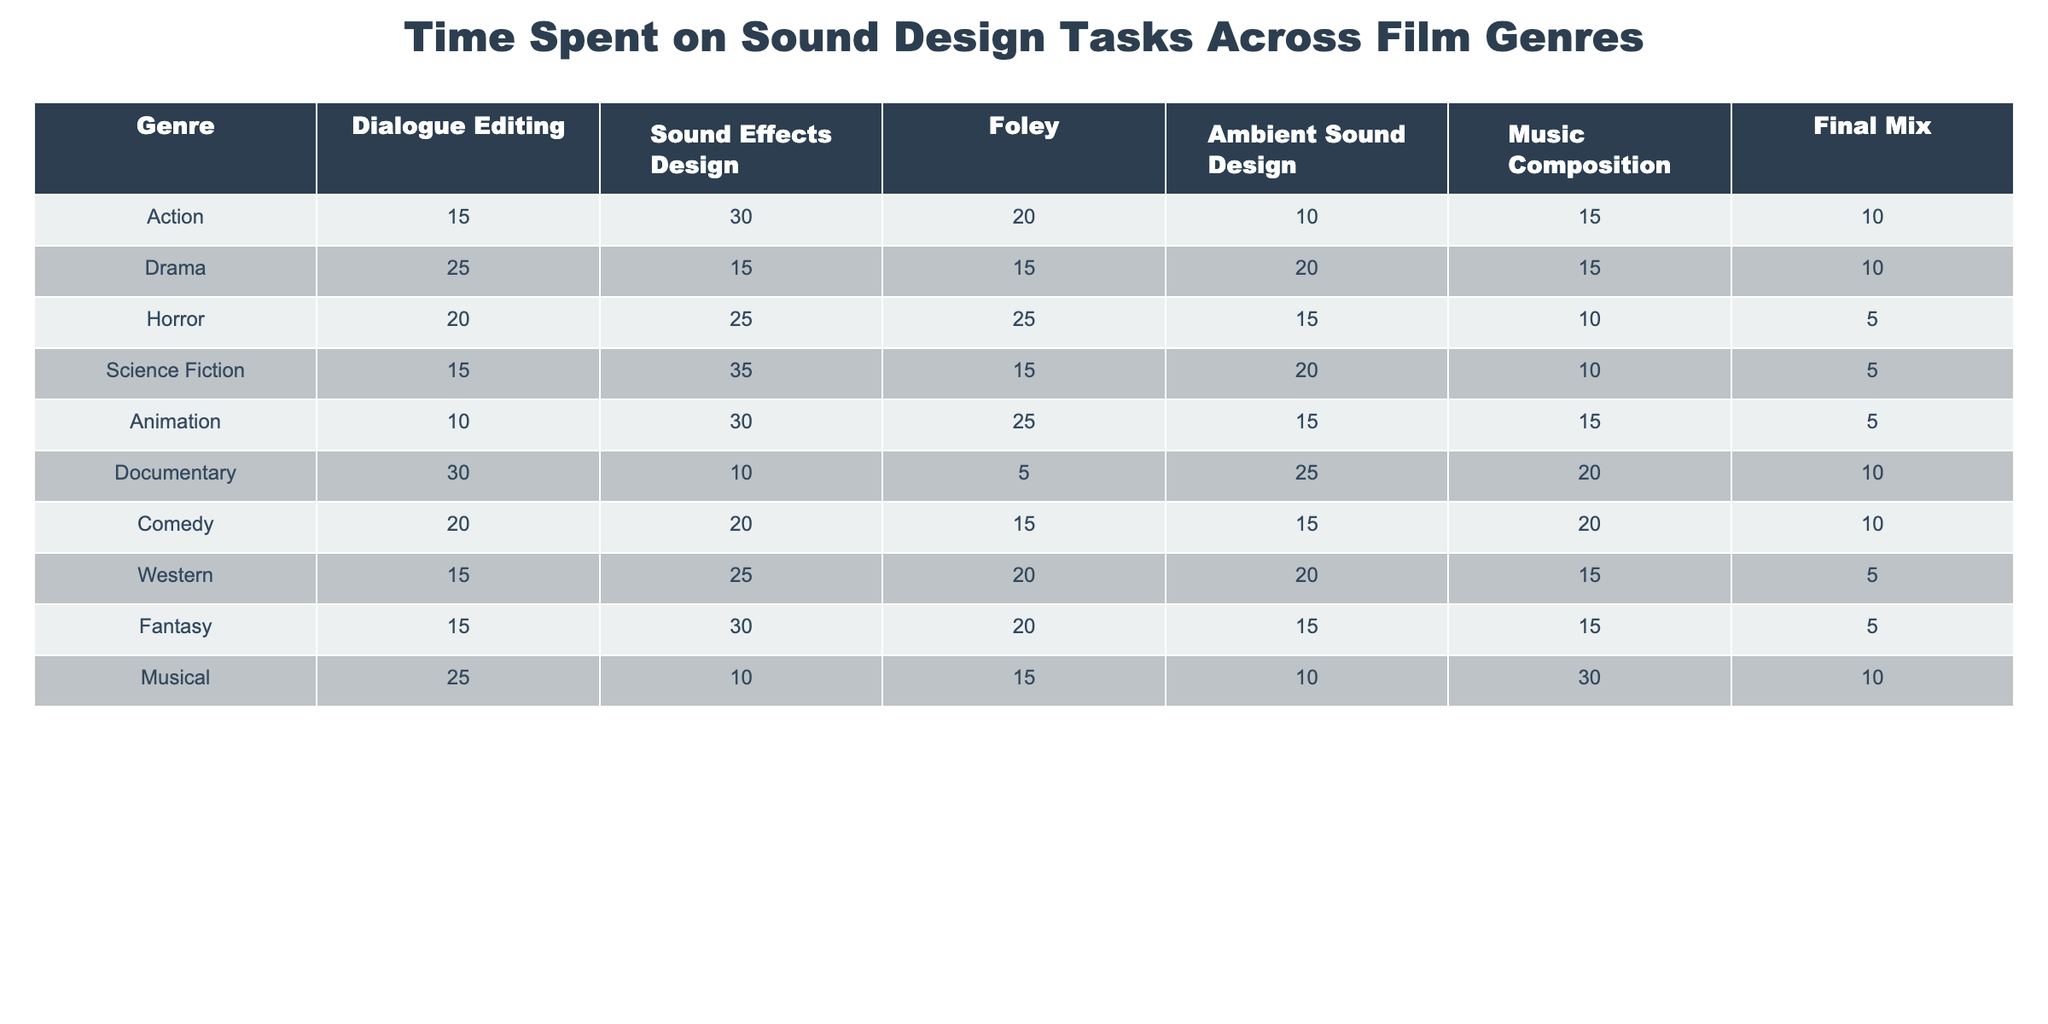What is the highest time spent on Dialogue Editing across all genres? The table shows that Documentary has the highest time spent on Dialogue Editing at 30 minutes.
Answer: 30 Which genre spends the most time on Ambient Sound Design? According to the table, Documentary spends the most time on Ambient Sound Design with a total of 25 minutes.
Answer: 25 What is the total time spent on Sound Effects Design in the Action genre? The Action genre has 30 minutes spent on Sound Effects Design, which is directly stated in the table.
Answer: 30 Does the genre Animation spend more time on Foley or Music Composition? Animation spends 25 minutes on Foley and 15 minutes on Music Composition; therefore, it spends more time on Foley.
Answer: Yes What genre has the lowest total time spent on all tasks? To find the genre with the lowest total time, we add the time for each task in every genre. The genre with the lowest total is Musical with 90 minutes.
Answer: Musical Which genre has the largest difference in time between Sound Effects Design and Foley? For Action, the time spent on Sound Effects Design is 30 minutes and on Foley is 20 minutes, resulting in a difference of 10 minutes. The largest difference is in Horror, with 25 minutes for Sound Effects and 25 for Foley, yielding a difference of 0. The genre with the largest difference is Action.
Answer: Action What is the average time spent on Music Composition across all genres? The Music Composition times are 15, 15, 10, 10, 15, 20, 20, 15, 30, and 30. Summing these values provides 175 minutes, and dividing by 10 (the number of genres) results in an average of 17.5 minutes.
Answer: 17.5 In which genre is the time spent on Dialogue Editing greater than the total of Music Composition and Final Mix combined? For Drama, Dialogue Editing is 25, Music Composition and Final Mix are 15 and 10 respectively, totaling 25 which is equal. For the Horror genre, Dialogue Editing is 20, Music Composition and Final Mix total 15, which is less than Dialogue Editing. Thus, the genres where Dialogue Editing is greater than the sum are Horror and others such as Action.
Answer: Horror Is there any genre where the time spent on Sound Effects Design is equal to the time spent on Final Mix? The genres Comedy and Documentary both show 10 minutes spent on Sound Effects Design and Final Mix, which means they are equal for these genres.
Answer: Yes Which genre has the highest total time spent across all sound design tasks? To find the highest total, we sum the time for each task across all genres. The totals are as follows: Action - 100, Drama - 100, Horror - 100, Science Fiction - 95, Animation - 100, Documentary - 100, Comedy - 100, Western - 95, Fantasy - 90, Musical - 90. The maximum value is 100, shared among Action, Drama, Horror, Animation, Documentary, and Comedy.
Answer: Action, Drama, Horror, Animation, Documentary, Comedy 